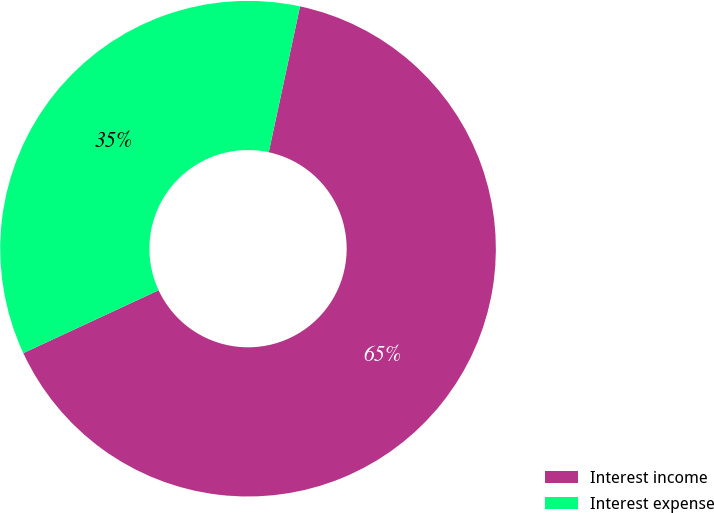Convert chart to OTSL. <chart><loc_0><loc_0><loc_500><loc_500><pie_chart><fcel>Interest income<fcel>Interest expense<nl><fcel>64.71%<fcel>35.29%<nl></chart> 